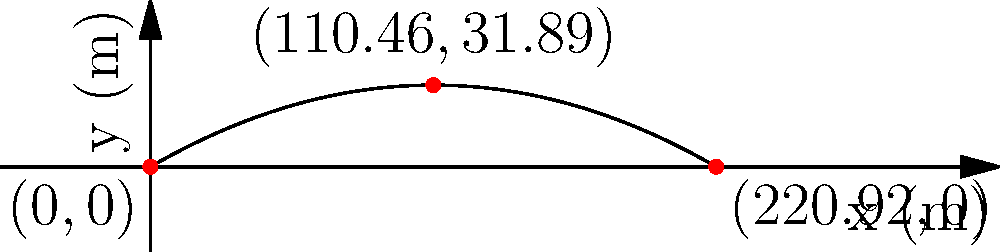As a web developer familiar with error handling, you're designing a game that simulates projectile motion. You need to calculate the trajectory of a projectile launched with an initial velocity of 50 m/s at an angle of 30° above the horizontal. Assuming no air resistance, determine:

a) The maximum height reached by the projectile
b) The total horizontal distance traveled
c) The time of flight

Round your answers to two decimal places. Let's approach this step-by-step, using the equations of motion for projectile trajectories:

1) First, let's break down the initial velocity into its x and y components:
   $v_{0x} = v_0 \cos(\theta) = 50 \cos(30°) = 43.30$ m/s
   $v_{0y} = v_0 \sin(\theta) = 50 \sin(30°) = 25$ m/s

2) To find the maximum height (a):
   We use the equation: $y_{max} = \frac{v_{0y}^2}{2g}$
   Where g is the acceleration due to gravity (9.8 m/s²)
   $y_{max} = \frac{25^2}{2(9.8)} = 31.89$ m

3) For the total horizontal distance (b):
   We use the equation: $x_{max} = \frac{2v_0^2\sin(\theta)\cos(\theta)}{g}$
   $x_{max} = \frac{2(50^2)\sin(30°)\cos(30°)}{9.8} = 220.97$ m

4) To calculate the time of flight (c):
   We can use: $t_{flight} = \frac{2v_{0y}}{g} = \frac{2v_0\sin(\theta)}{g}$
   $t_{flight} = \frac{2(50)\sin(30°)}{9.8} = 5.10$ s

Rounding to two decimal places:
a) Maximum height: 31.89 m
b) Total horizontal distance: 220.97 m
c) Time of flight: 5.10 s
Answer: a) 31.89 m
b) 220.97 m
c) 5.10 s 